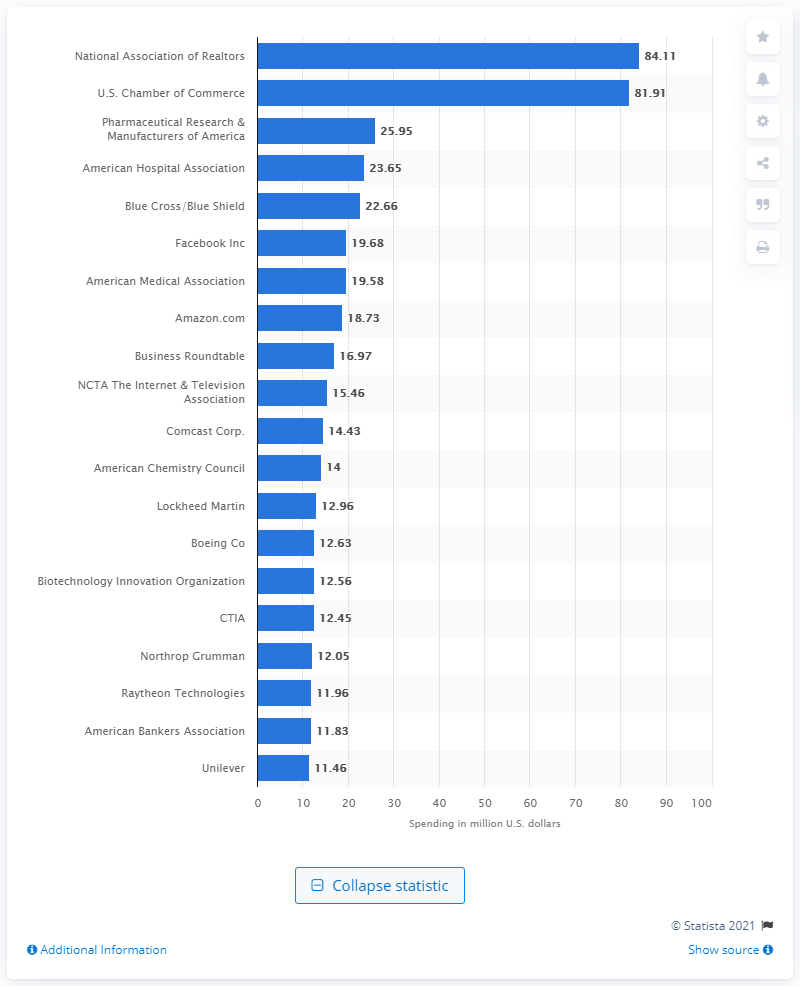Indicate a few pertinent items in this graphic. According to data from 2020, the National Association of Realtors was the top spender on lobbying in the United States. The National Association of Realtors spent $84.11 on lobbying in 2020. 